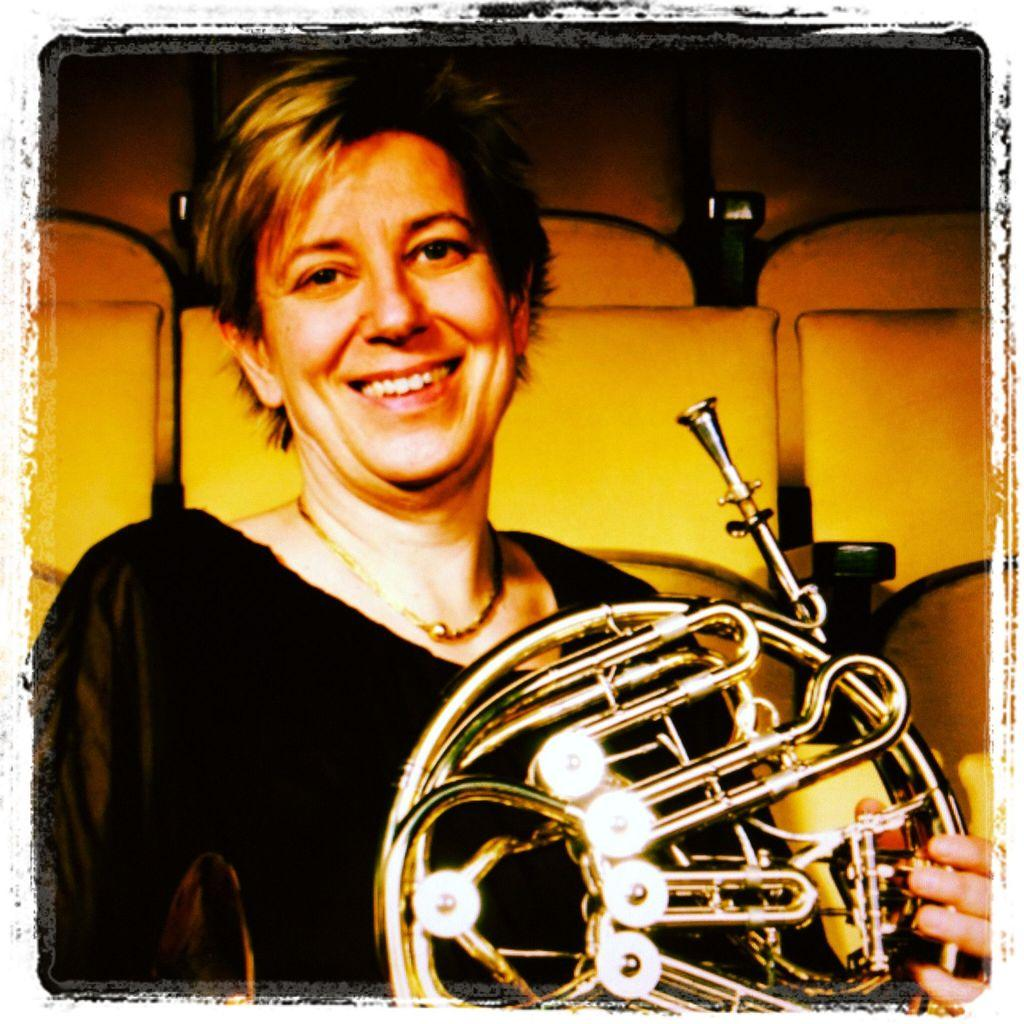What is the person in the image holding? The person is holding a musical instrument in the image. Can you describe the person's attire? The person is wearing a black dress. What colors of lighting can be seen in the background of the image? There is yellow and black color lighting visible in the background of the image. How does the beggar in the image make their wish come true? There is no beggar present in the image, and therefore no wish can be granted. 